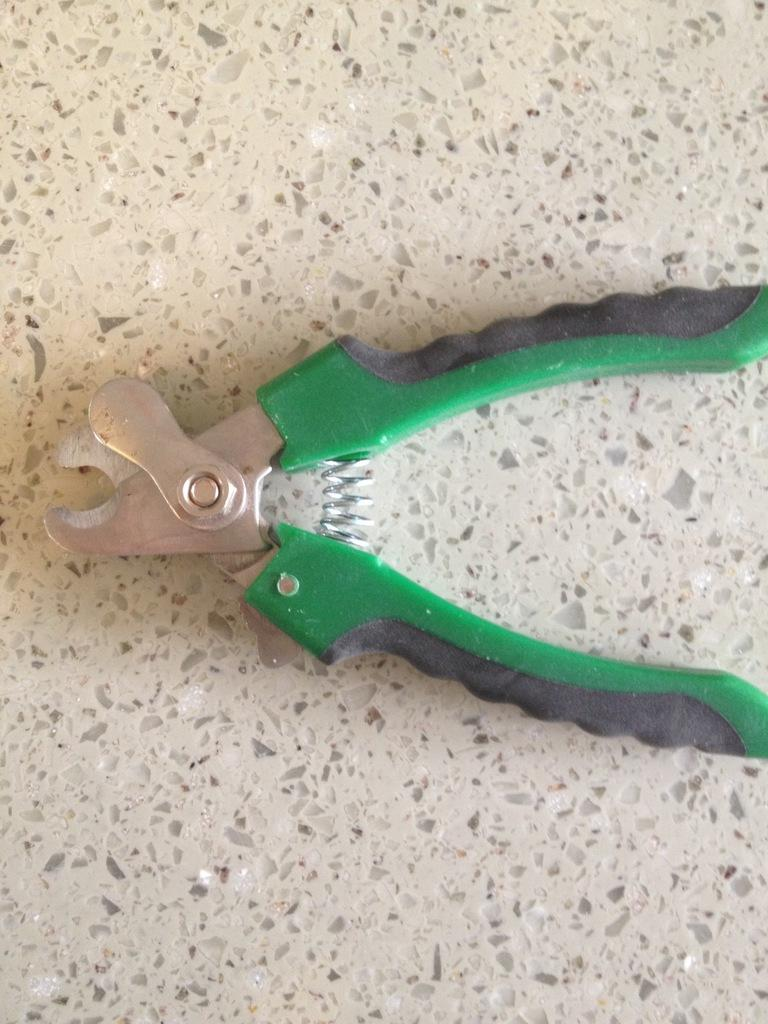What tool is visible in the image? There is a wire stripper in the image. Where is the wire stripper located in the image? The wire stripper is on the floor. What type of pie is being served on the neck in the image? There is no pie or neck present in the image; it only features a wire stripper on the floor. 